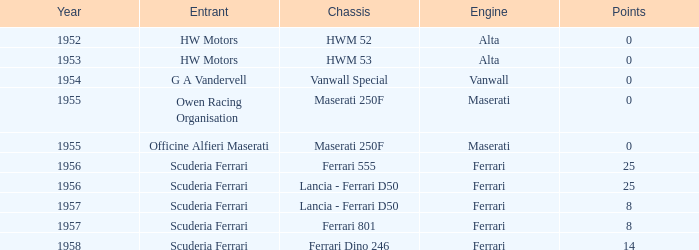What company made the chassis when Ferrari made the engine and there were 25 points? Ferrari 555, Lancia - Ferrari D50. 